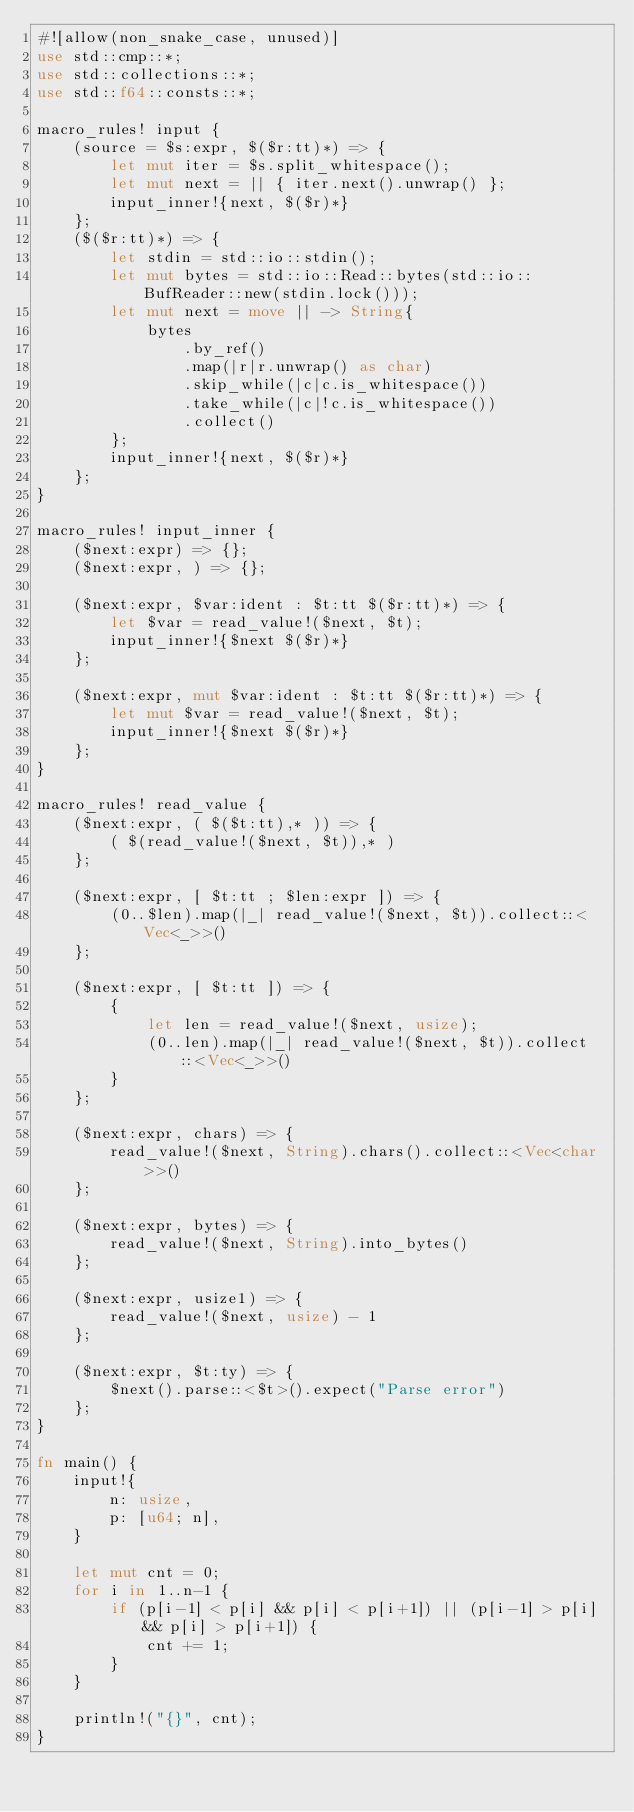<code> <loc_0><loc_0><loc_500><loc_500><_Rust_>#![allow(non_snake_case, unused)]
use std::cmp::*;
use std::collections::*;
use std::f64::consts::*;

macro_rules! input {
    (source = $s:expr, $($r:tt)*) => {
        let mut iter = $s.split_whitespace();
        let mut next = || { iter.next().unwrap() };
        input_inner!{next, $($r)*}
    };
    ($($r:tt)*) => {
        let stdin = std::io::stdin();
        let mut bytes = std::io::Read::bytes(std::io::BufReader::new(stdin.lock()));
        let mut next = move || -> String{
            bytes
                .by_ref()
                .map(|r|r.unwrap() as char)
                .skip_while(|c|c.is_whitespace())
                .take_while(|c|!c.is_whitespace())
                .collect()
        };
        input_inner!{next, $($r)*}
    };
}

macro_rules! input_inner {
    ($next:expr) => {};
    ($next:expr, ) => {};

    ($next:expr, $var:ident : $t:tt $($r:tt)*) => {
        let $var = read_value!($next, $t);
        input_inner!{$next $($r)*}
    };

    ($next:expr, mut $var:ident : $t:tt $($r:tt)*) => {
        let mut $var = read_value!($next, $t);
        input_inner!{$next $($r)*}
    };
}

macro_rules! read_value {
    ($next:expr, ( $($t:tt),* )) => {
        ( $(read_value!($next, $t)),* )
    };

    ($next:expr, [ $t:tt ; $len:expr ]) => {
        (0..$len).map(|_| read_value!($next, $t)).collect::<Vec<_>>()
    };

    ($next:expr, [ $t:tt ]) => {
        {
            let len = read_value!($next, usize);
            (0..len).map(|_| read_value!($next, $t)).collect::<Vec<_>>()
        }
    };

    ($next:expr, chars) => {
        read_value!($next, String).chars().collect::<Vec<char>>()
    };

    ($next:expr, bytes) => {
        read_value!($next, String).into_bytes()
    };

    ($next:expr, usize1) => {
        read_value!($next, usize) - 1
    };

    ($next:expr, $t:ty) => {
        $next().parse::<$t>().expect("Parse error")
    };
}

fn main() {
    input!{
        n: usize,
        p: [u64; n],
    }

    let mut cnt = 0;
    for i in 1..n-1 {
        if (p[i-1] < p[i] && p[i] < p[i+1]) || (p[i-1] > p[i] && p[i] > p[i+1]) {
            cnt += 1;
        }
    }
    
    println!("{}", cnt);
}
</code> 